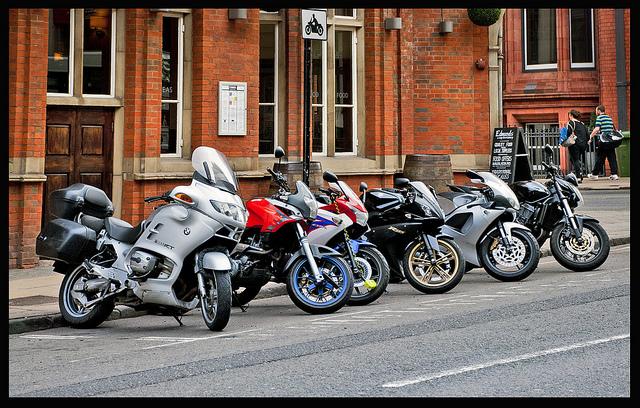How many bikes are there?
Be succinct. 6. How many people are walking?
Short answer required. 2. Are all of the tires facing the same way?
Short answer required. No. Is this a parking lot?
Keep it brief. No. 